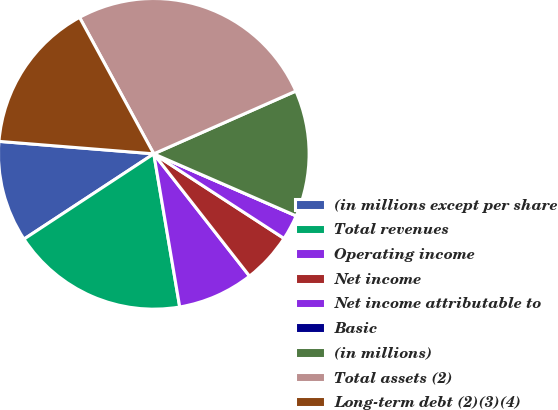Convert chart. <chart><loc_0><loc_0><loc_500><loc_500><pie_chart><fcel>(in millions except per share<fcel>Total revenues<fcel>Operating income<fcel>Net income<fcel>Net income attributable to<fcel>Basic<fcel>(in millions)<fcel>Total assets (2)<fcel>Long-term debt (2)(3)(4)<nl><fcel>10.53%<fcel>18.42%<fcel>7.9%<fcel>5.26%<fcel>2.63%<fcel>0.0%<fcel>13.16%<fcel>26.31%<fcel>15.79%<nl></chart> 